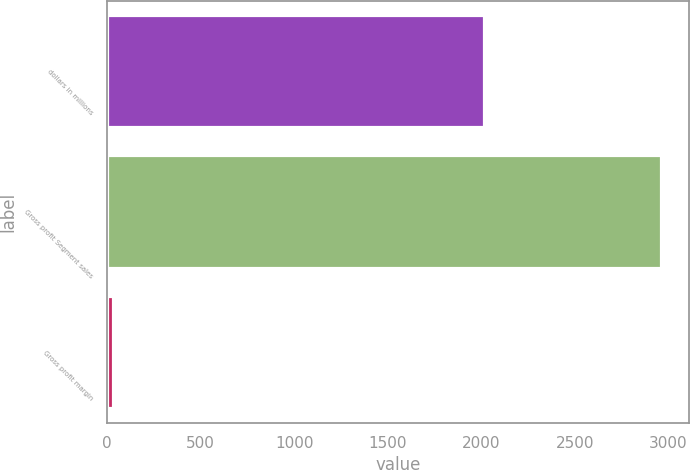Convert chart. <chart><loc_0><loc_0><loc_500><loc_500><bar_chart><fcel>dollars in millions<fcel>Gross profit Segment sales<fcel>Gross profit margin<nl><fcel>2016<fcel>2961.8<fcel>29.2<nl></chart> 